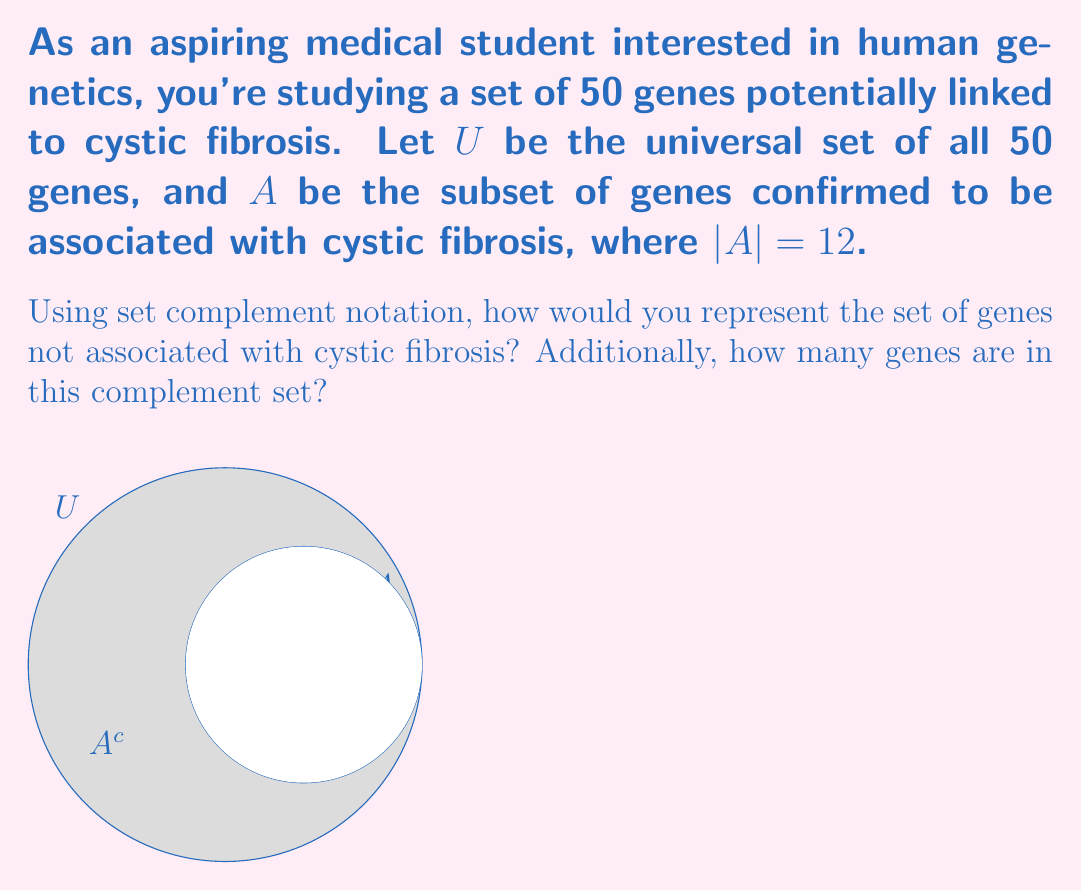Can you answer this question? Let's approach this step-by-step:

1) The universal set $U$ contains all 50 genes under study.

2) Set $A$ contains the 12 genes confirmed to be associated with cystic fibrosis.

3) The complement of set $A$, denoted as $A^c$ or $\overline{A}$, represents all elements in the universal set $U$ that are not in $A$. In this case, it would be all genes not associated with cystic fibrosis.

4) We can represent this mathematically as:

   $A^c = U \setminus A$

   This reads as "A complement equals U minus A" or "all elements in U that are not in A".

5) To find the number of genes in $A^c$, we can use the property:

   $|U| = |A| + |A^c|$

   Where $|U|$ is the total number of genes, $|A|$ is the number of genes associated with cystic fibrosis, and $|A^c|$ is the number of genes not associated with cystic fibrosis.

6) We know that $|U| = 50$ and $|A| = 12$. So:

   $50 = 12 + |A^c|$
   $|A^c| = 50 - 12 = 38$

Therefore, there are 38 genes in the complement set $A^c$.
Answer: $A^c = U \setminus A$; 38 genes 